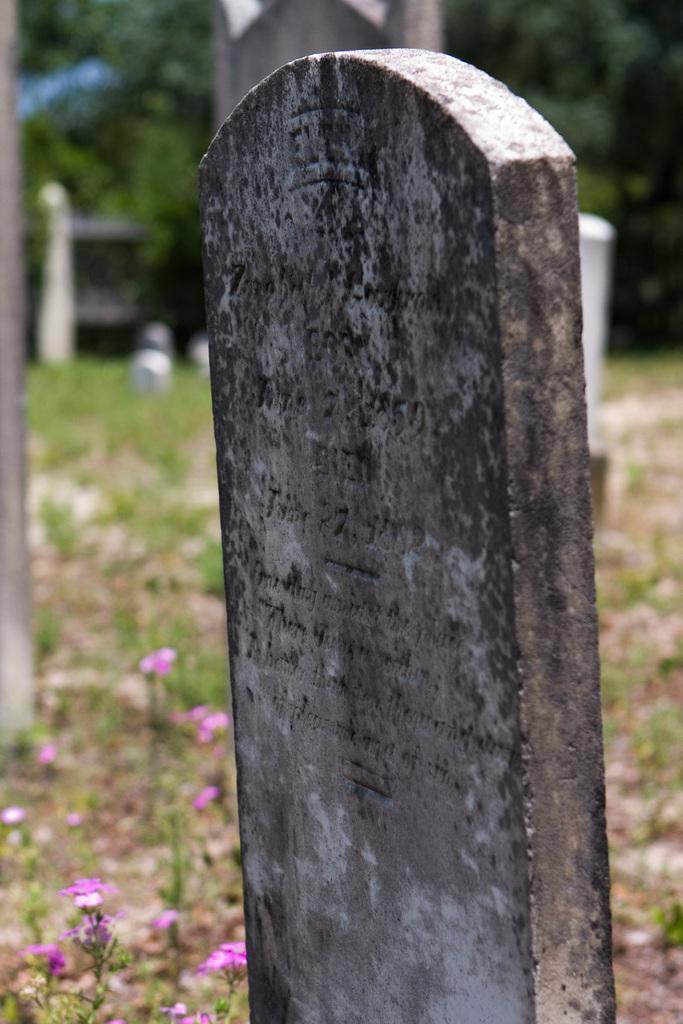In one or two sentences, can you explain what this image depicts? In this image we can see there are some gravestones, trees and plants with flowers on it. 